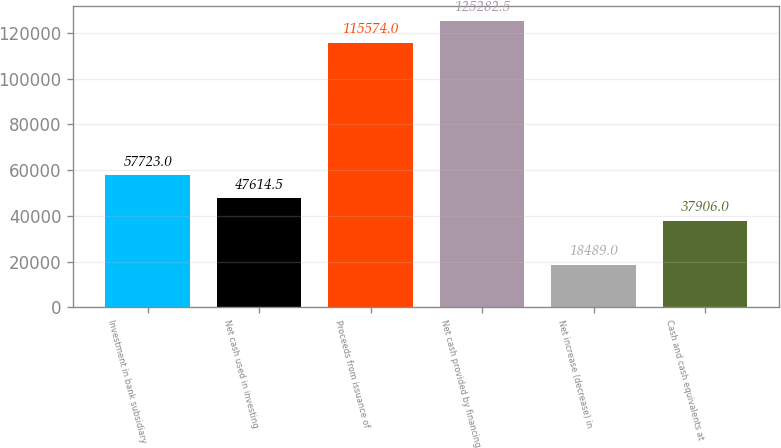<chart> <loc_0><loc_0><loc_500><loc_500><bar_chart><fcel>Investment in bank subsidiary<fcel>Net cash used in investing<fcel>Proceeds from issuance of<fcel>Net cash provided by financing<fcel>Net increase (decrease) in<fcel>Cash and cash equivalents at<nl><fcel>57723<fcel>47614.5<fcel>115574<fcel>125282<fcel>18489<fcel>37906<nl></chart> 